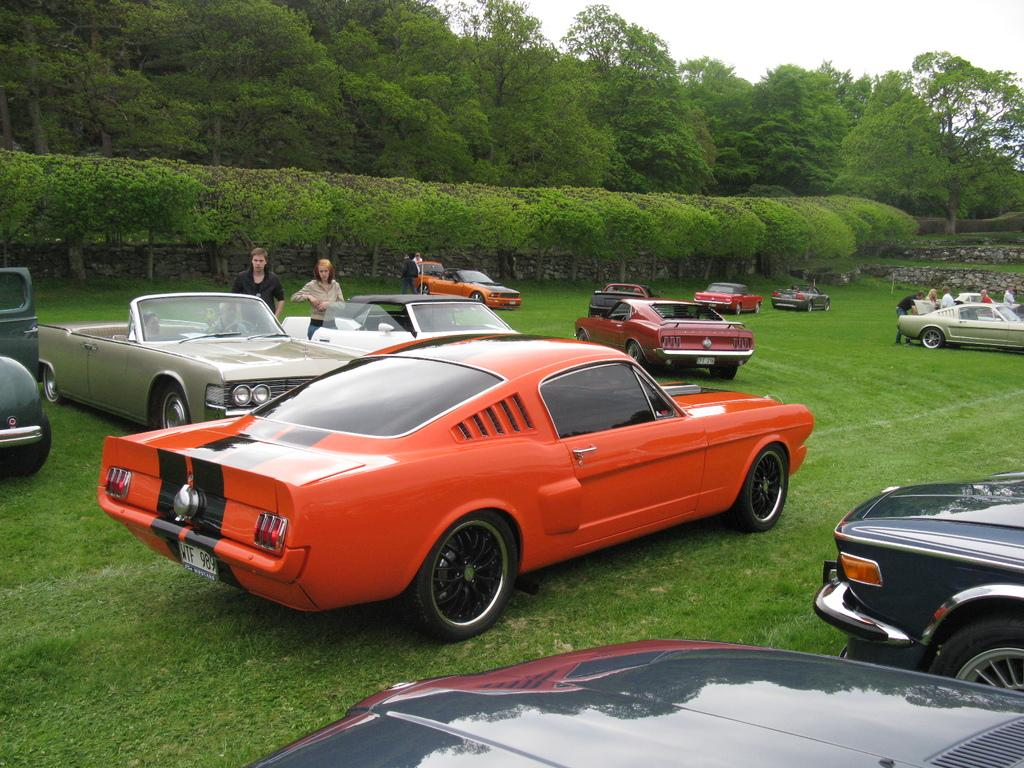What can be seen in the foreground of the picture? There are cars, people, and grass in the foreground of the picture. What is located in the center of the picture? There are trees in the center of the picture. What is present in the background of the picture? There are trees in the background of the picture. How would you describe the sky in the image? The sky is cloudy in the image. What type of sound can be heard coming from the square in the image? There is no square present in the image, so it is not possible to determine what sound might be heard. 